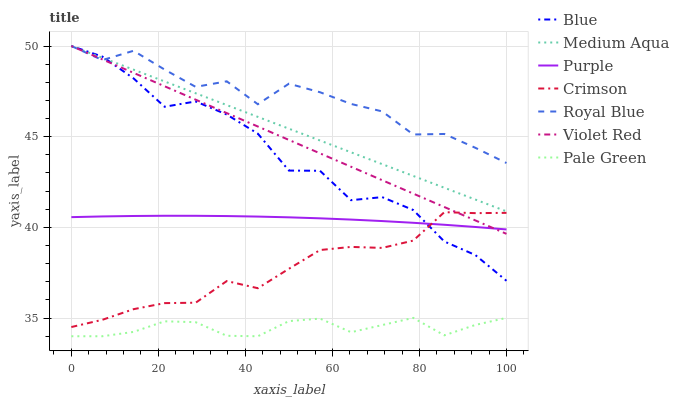Does Pale Green have the minimum area under the curve?
Answer yes or no. Yes. Does Royal Blue have the maximum area under the curve?
Answer yes or no. Yes. Does Violet Red have the minimum area under the curve?
Answer yes or no. No. Does Violet Red have the maximum area under the curve?
Answer yes or no. No. Is Medium Aqua the smoothest?
Answer yes or no. Yes. Is Blue the roughest?
Answer yes or no. Yes. Is Violet Red the smoothest?
Answer yes or no. No. Is Violet Red the roughest?
Answer yes or no. No. Does Violet Red have the lowest value?
Answer yes or no. No. Does Purple have the highest value?
Answer yes or no. No. Is Purple less than Royal Blue?
Answer yes or no. Yes. Is Crimson greater than Pale Green?
Answer yes or no. Yes. Does Purple intersect Royal Blue?
Answer yes or no. No. 